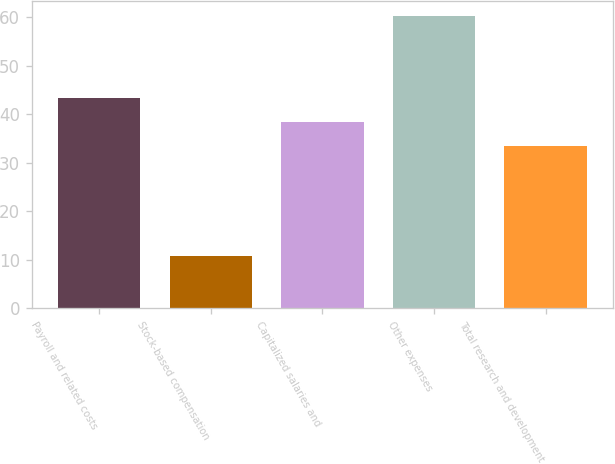<chart> <loc_0><loc_0><loc_500><loc_500><bar_chart><fcel>Payroll and related costs<fcel>Stock-based compensation<fcel>Capitalized salaries and<fcel>Other expenses<fcel>Total research and development<nl><fcel>43.4<fcel>10.8<fcel>38.45<fcel>60.3<fcel>33.5<nl></chart> 